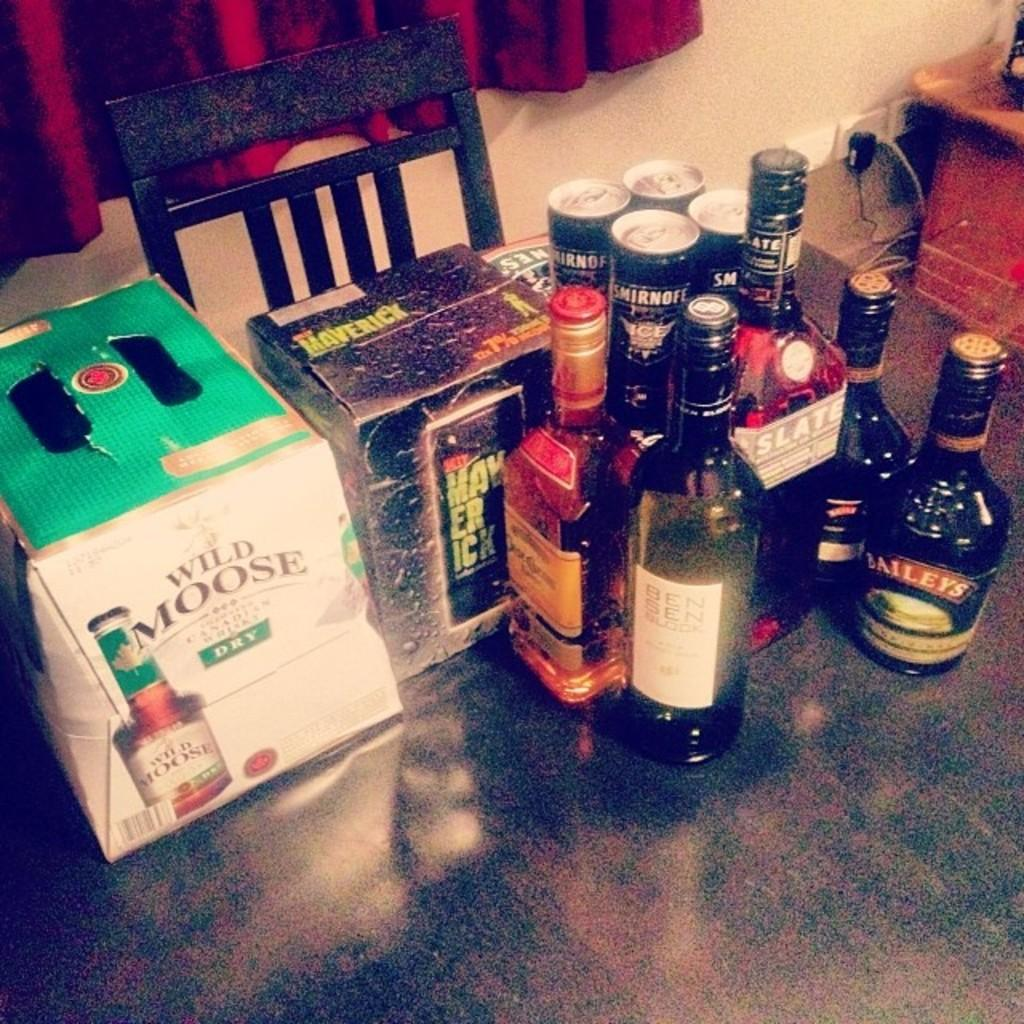What piece of furniture is present in the image? There is a table in the image. What items can be seen on the table? There are bottles and boxes on the table. What type of seating is visible in the image? There is a chair in the image. What type of window treatment is present in the image? There is a curtain in the image. What surface is visible beneath the table and chair? There is a floor visible in the image. What type of yak is standing next to the table in the image? There is no yak present in the image. What type of trousers is the person wearing in the image? There is no person visible in the image, so it is impossible to determine what type of trousers they might be wearing. 